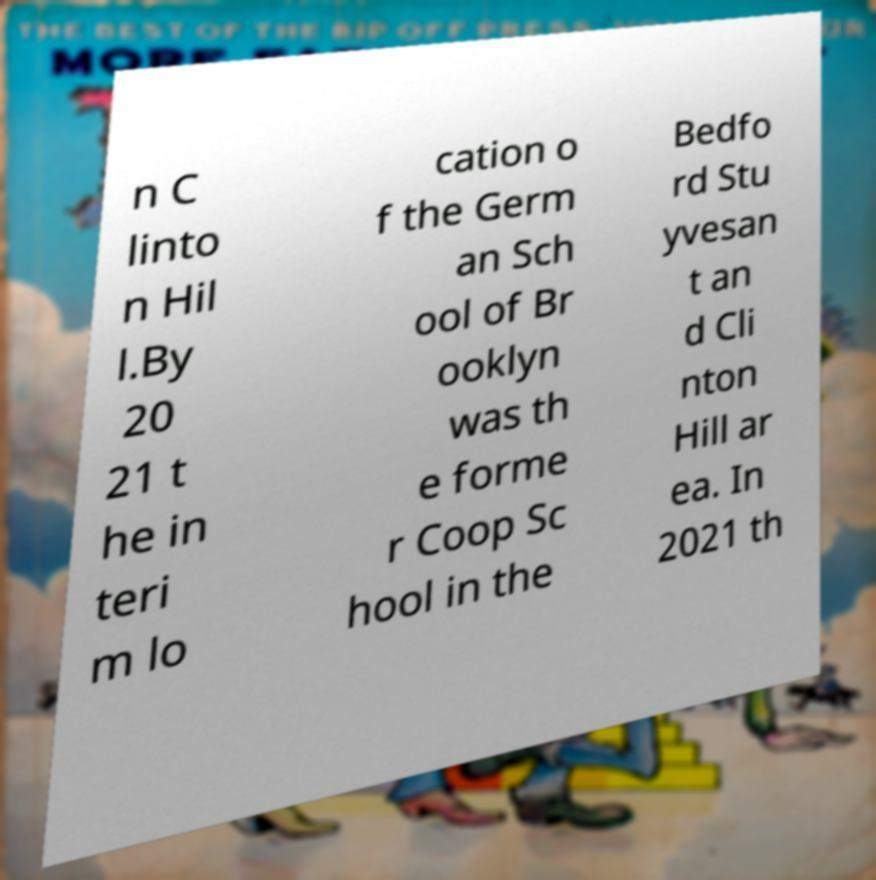Could you extract and type out the text from this image? n C linto n Hil l.By 20 21 t he in teri m lo cation o f the Germ an Sch ool of Br ooklyn was th e forme r Coop Sc hool in the Bedfo rd Stu yvesan t an d Cli nton Hill ar ea. In 2021 th 